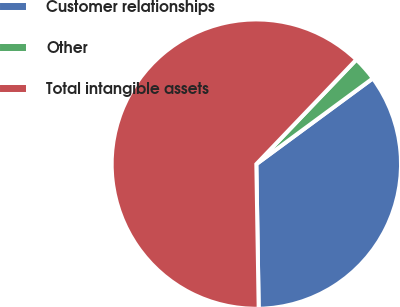<chart> <loc_0><loc_0><loc_500><loc_500><pie_chart><fcel>Customer relationships<fcel>Other<fcel>Total intangible assets<nl><fcel>34.84%<fcel>2.75%<fcel>62.41%<nl></chart> 